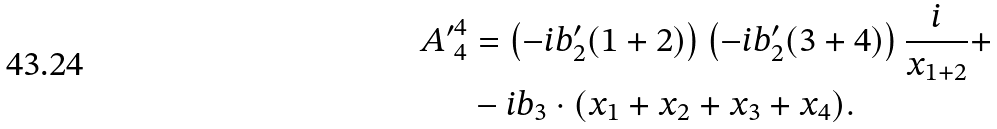<formula> <loc_0><loc_0><loc_500><loc_500>{ A ^ { \prime } } ^ { 4 } _ { 4 } & = \left ( - i b ^ { \prime } _ { 2 } ( 1 + 2 ) \right ) \left ( - i b ^ { \prime } _ { 2 } ( 3 + 4 ) \right ) \frac { i } { x _ { 1 + 2 } } + \\ & - i b _ { 3 } \cdot ( x _ { 1 } + x _ { 2 } + x _ { 3 } + x _ { 4 } ) .</formula> 